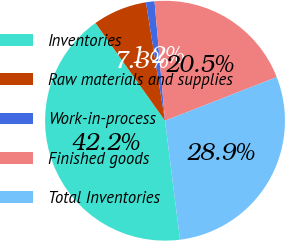<chart> <loc_0><loc_0><loc_500><loc_500><pie_chart><fcel>Inventories<fcel>Raw materials and supplies<fcel>Work-in-process<fcel>Finished goods<fcel>Total Inventories<nl><fcel>42.15%<fcel>7.3%<fcel>1.15%<fcel>20.47%<fcel>28.92%<nl></chart> 